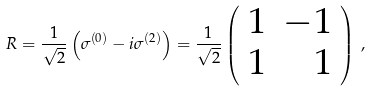<formula> <loc_0><loc_0><loc_500><loc_500>R = \frac { 1 } { \sqrt { 2 } } \left ( \sigma ^ { ( 0 ) } - i \sigma ^ { ( 2 ) } \right ) = \frac { 1 } { \sqrt { 2 } } \left ( \begin{array} { r r } 1 & - 1 \\ 1 & 1 \end{array} \right ) \, ,</formula> 